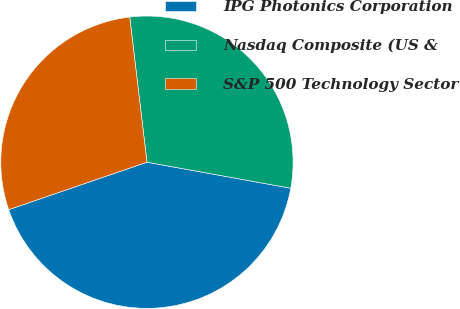Convert chart. <chart><loc_0><loc_0><loc_500><loc_500><pie_chart><fcel>IPG Photonics Corporation<fcel>Nasdaq Composite (US &<fcel>S&P 500 Technology Sector<nl><fcel>41.88%<fcel>29.73%<fcel>28.38%<nl></chart> 